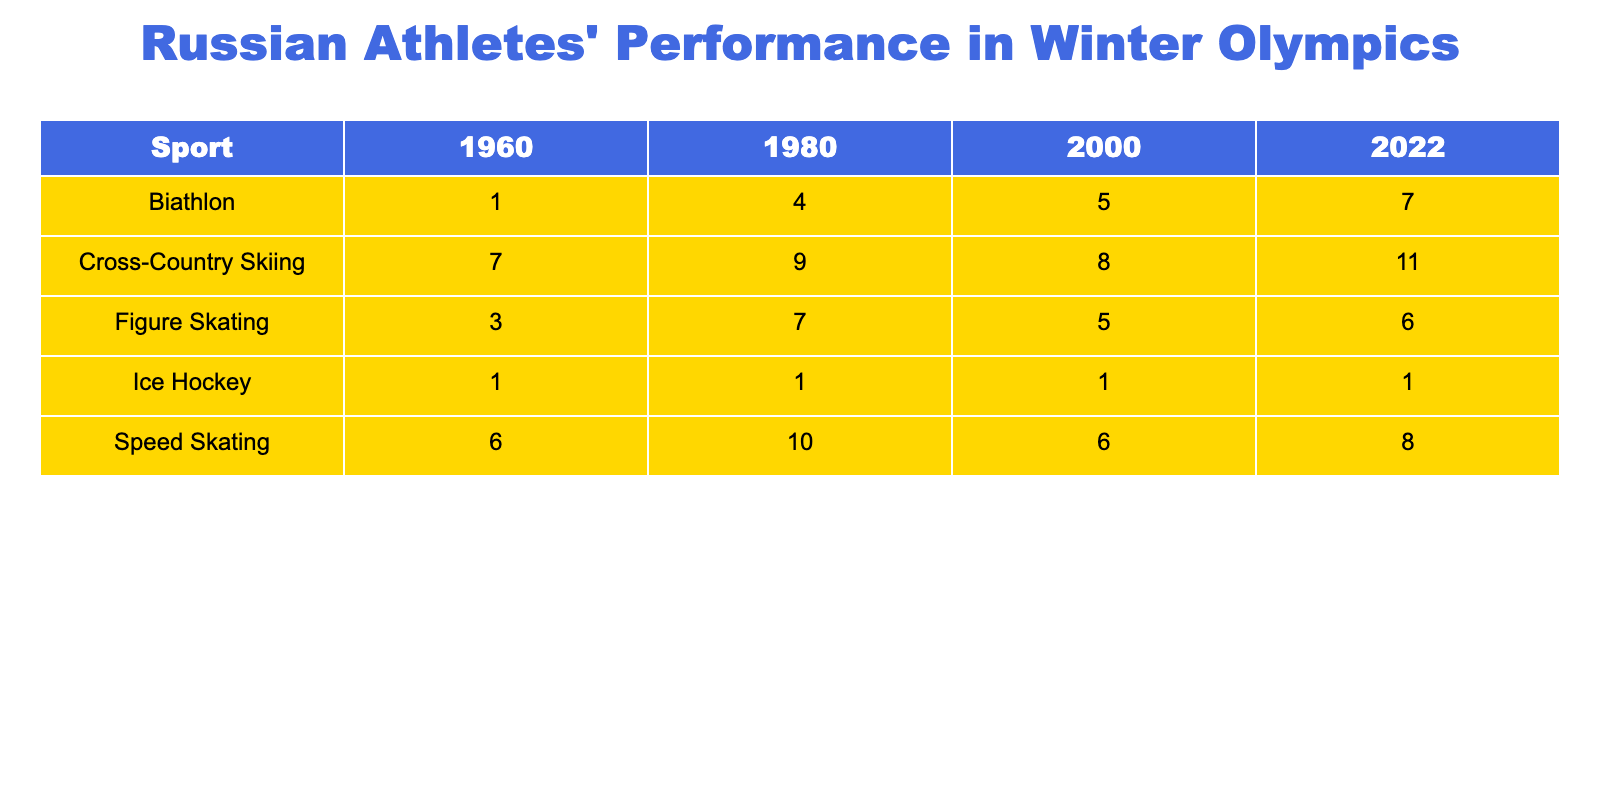What sport had the highest total medals in 2022? By looking at the total column for the year 2022, we see that Cross-Country Skiing has the highest total of 11 medals.
Answer: Cross-Country Skiing How many total medals did Russia win in Figure Skating across all years? We add the total medals for Figure Skating across the years: 3 (1960) + 7 (1980) + 5 (2000) + 6 (2022) = 21.
Answer: 21 What is the total number of Gold medals won by Russian athletes in Biathlon from 1980 to 2022? We take the Gold medals for Biathlon for the years 1980 (2), 2000 (1), and 2022 (3), then sum them: 2 + 1 + 3 = 6.
Answer: 6 Did Russia win any Gold medals in Ice Hockey in the year 2000? The table shows there are 0 Gold medals for Ice Hockey in 2000.
Answer: No Which sport showed consistent improvement in total medals from 1960 to 2022? If we compare the total medals across the years for each sport, Cross-Country Skiing has increased from 7 in 1960 to 11 in 2022 and has consistently improved each year.
Answer: Cross-Country Skiing What is the difference in total medals won by Russia in Speed Skating between 1980 and 2022? The total medals for Speed Skating in 1980 are 10, and in 2022 they are 8. The difference is 10 - 8 = 2.
Answer: 2 In which discipline did Russia win more Silver medals in 2022 compared to 2000? Looking at the Silver medals in 2022 (2) and 2000 (2) for Biathlon, in Figure Skating (3 vs 2), Cross-Country Skiing (4 vs 4), and Speed Skating (3 vs 3), only in Figure Skating did they win more Silver medals in 2022 compared to 2000.
Answer: Figure Skating What was the total number of Bronze medals won in Cross-Country Skiing from 1980 to 2022? We sum the Bronze medals for Cross-Country Skiing: 2 (1980) + 1 (2000) + 3 (2022) = 6.
Answer: 6 Is it true that Russia has never won a Gold medal in Ice Hockey during the years represented in the table? Since the table shows 0 Gold medals in Ice Hockey for all years, this statement is true.
Answer: True What sport had the lowest total medals overall and what was the total? Ice Hockey has the lowest total medals with 4 across all years (1 in 1960, 1 in 1980, 1 in 2000, 1 in 2022).
Answer: Ice Hockey, 4 